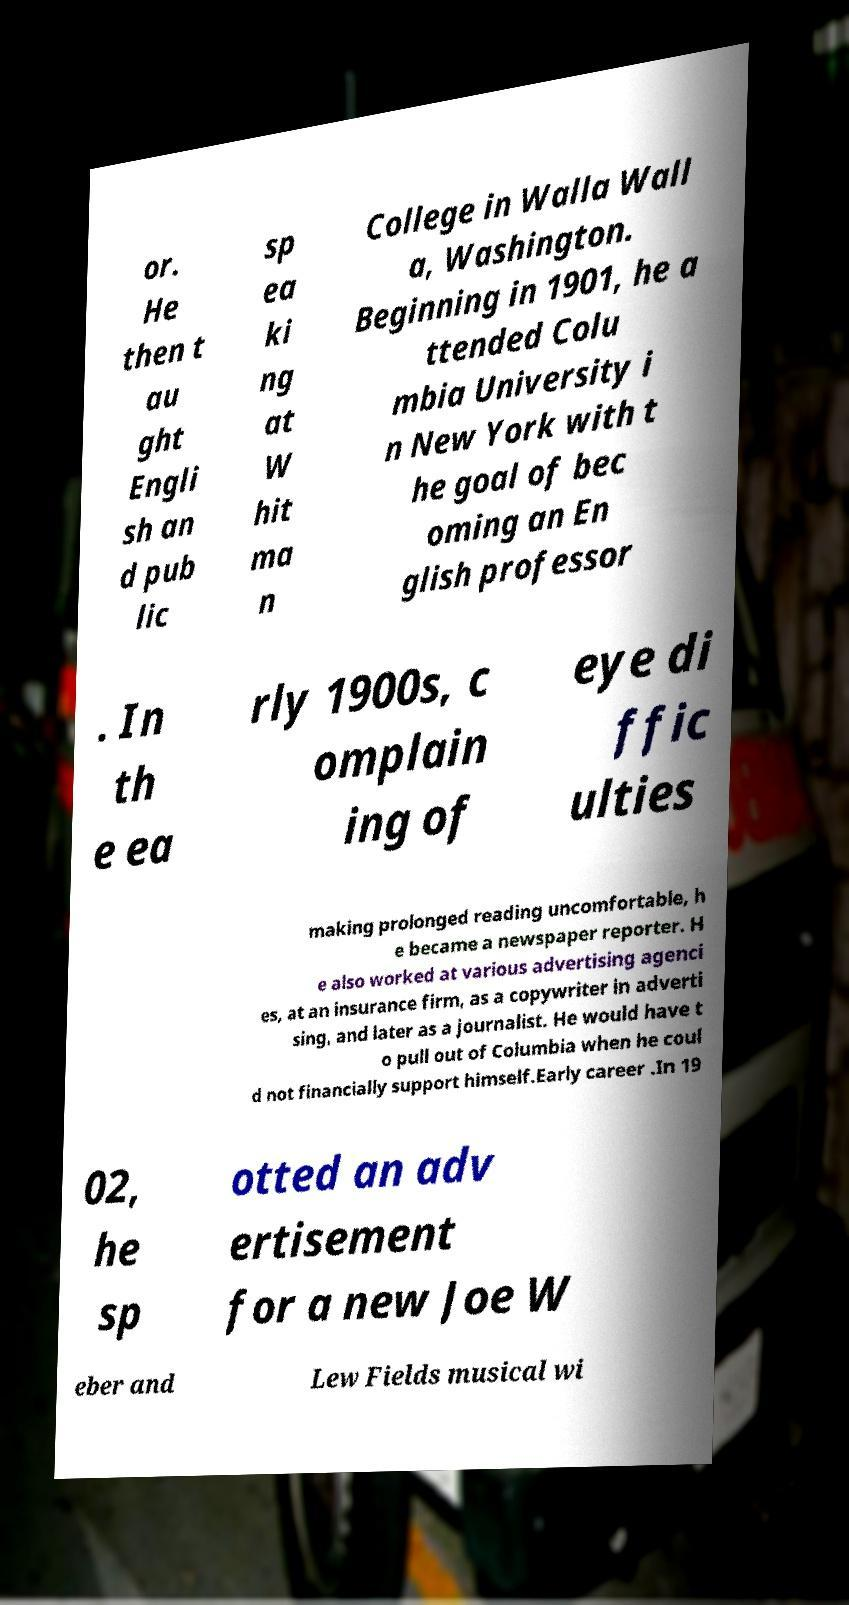I need the written content from this picture converted into text. Can you do that? or. He then t au ght Engli sh an d pub lic sp ea ki ng at W hit ma n College in Walla Wall a, Washington. Beginning in 1901, he a ttended Colu mbia University i n New York with t he goal of bec oming an En glish professor . In th e ea rly 1900s, c omplain ing of eye di ffic ulties making prolonged reading uncomfortable, h e became a newspaper reporter. H e also worked at various advertising agenci es, at an insurance firm, as a copywriter in adverti sing, and later as a journalist. He would have t o pull out of Columbia when he coul d not financially support himself.Early career .In 19 02, he sp otted an adv ertisement for a new Joe W eber and Lew Fields musical wi 